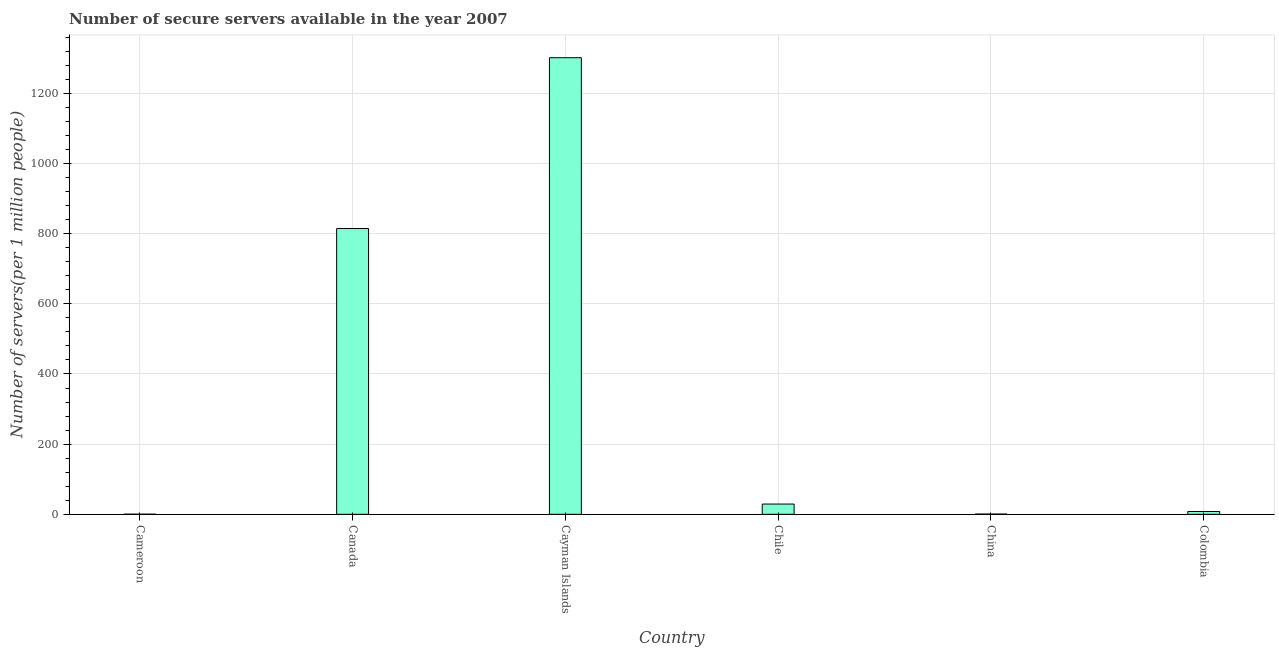What is the title of the graph?
Offer a terse response. Number of secure servers available in the year 2007. What is the label or title of the Y-axis?
Your answer should be very brief. Number of servers(per 1 million people). What is the number of secure internet servers in Chile?
Your answer should be very brief. 29.28. Across all countries, what is the maximum number of secure internet servers?
Your response must be concise. 1301.48. Across all countries, what is the minimum number of secure internet servers?
Offer a terse response. 0.37. In which country was the number of secure internet servers maximum?
Your answer should be compact. Cayman Islands. In which country was the number of secure internet servers minimum?
Offer a very short reply. Cameroon. What is the sum of the number of secure internet servers?
Make the answer very short. 2154.34. What is the difference between the number of secure internet servers in Cameroon and China?
Give a very brief answer. -0.32. What is the average number of secure internet servers per country?
Offer a very short reply. 359.06. What is the median number of secure internet servers?
Ensure brevity in your answer.  18.63. What is the ratio of the number of secure internet servers in Cayman Islands to that in Chile?
Ensure brevity in your answer.  44.45. Is the number of secure internet servers in Cameroon less than that in Colombia?
Provide a short and direct response. Yes. What is the difference between the highest and the second highest number of secure internet servers?
Keep it short and to the point. 486.92. What is the difference between the highest and the lowest number of secure internet servers?
Make the answer very short. 1301.11. In how many countries, is the number of secure internet servers greater than the average number of secure internet servers taken over all countries?
Your answer should be compact. 2. How many bars are there?
Make the answer very short. 6. How many countries are there in the graph?
Ensure brevity in your answer.  6. Are the values on the major ticks of Y-axis written in scientific E-notation?
Offer a very short reply. No. What is the Number of servers(per 1 million people) of Cameroon?
Your answer should be compact. 0.37. What is the Number of servers(per 1 million people) of Canada?
Offer a terse response. 814.55. What is the Number of servers(per 1 million people) in Cayman Islands?
Make the answer very short. 1301.48. What is the Number of servers(per 1 million people) of Chile?
Your answer should be compact. 29.28. What is the Number of servers(per 1 million people) in China?
Keep it short and to the point. 0.68. What is the Number of servers(per 1 million people) in Colombia?
Provide a short and direct response. 7.98. What is the difference between the Number of servers(per 1 million people) in Cameroon and Canada?
Give a very brief answer. -814.19. What is the difference between the Number of servers(per 1 million people) in Cameroon and Cayman Islands?
Ensure brevity in your answer.  -1301.11. What is the difference between the Number of servers(per 1 million people) in Cameroon and Chile?
Make the answer very short. -28.91. What is the difference between the Number of servers(per 1 million people) in Cameroon and China?
Make the answer very short. -0.32. What is the difference between the Number of servers(per 1 million people) in Cameroon and Colombia?
Offer a terse response. -7.61. What is the difference between the Number of servers(per 1 million people) in Canada and Cayman Islands?
Ensure brevity in your answer.  -486.92. What is the difference between the Number of servers(per 1 million people) in Canada and Chile?
Provide a short and direct response. 785.28. What is the difference between the Number of servers(per 1 million people) in Canada and China?
Provide a short and direct response. 813.87. What is the difference between the Number of servers(per 1 million people) in Canada and Colombia?
Your response must be concise. 806.58. What is the difference between the Number of servers(per 1 million people) in Cayman Islands and Chile?
Offer a very short reply. 1272.2. What is the difference between the Number of servers(per 1 million people) in Cayman Islands and China?
Your response must be concise. 1300.79. What is the difference between the Number of servers(per 1 million people) in Cayman Islands and Colombia?
Your answer should be very brief. 1293.5. What is the difference between the Number of servers(per 1 million people) in Chile and China?
Offer a very short reply. 28.6. What is the difference between the Number of servers(per 1 million people) in Chile and Colombia?
Ensure brevity in your answer.  21.3. What is the difference between the Number of servers(per 1 million people) in China and Colombia?
Ensure brevity in your answer.  -7.29. What is the ratio of the Number of servers(per 1 million people) in Cameroon to that in Canada?
Your answer should be compact. 0. What is the ratio of the Number of servers(per 1 million people) in Cameroon to that in Chile?
Keep it short and to the point. 0.01. What is the ratio of the Number of servers(per 1 million people) in Cameroon to that in China?
Your answer should be compact. 0.54. What is the ratio of the Number of servers(per 1 million people) in Cameroon to that in Colombia?
Ensure brevity in your answer.  0.05. What is the ratio of the Number of servers(per 1 million people) in Canada to that in Cayman Islands?
Give a very brief answer. 0.63. What is the ratio of the Number of servers(per 1 million people) in Canada to that in Chile?
Provide a short and direct response. 27.82. What is the ratio of the Number of servers(per 1 million people) in Canada to that in China?
Provide a short and direct response. 1192.77. What is the ratio of the Number of servers(per 1 million people) in Canada to that in Colombia?
Give a very brief answer. 102.11. What is the ratio of the Number of servers(per 1 million people) in Cayman Islands to that in Chile?
Your answer should be very brief. 44.45. What is the ratio of the Number of servers(per 1 million people) in Cayman Islands to that in China?
Provide a succinct answer. 1905.77. What is the ratio of the Number of servers(per 1 million people) in Cayman Islands to that in Colombia?
Give a very brief answer. 163.14. What is the ratio of the Number of servers(per 1 million people) in Chile to that in China?
Keep it short and to the point. 42.87. What is the ratio of the Number of servers(per 1 million people) in Chile to that in Colombia?
Offer a very short reply. 3.67. What is the ratio of the Number of servers(per 1 million people) in China to that in Colombia?
Give a very brief answer. 0.09. 